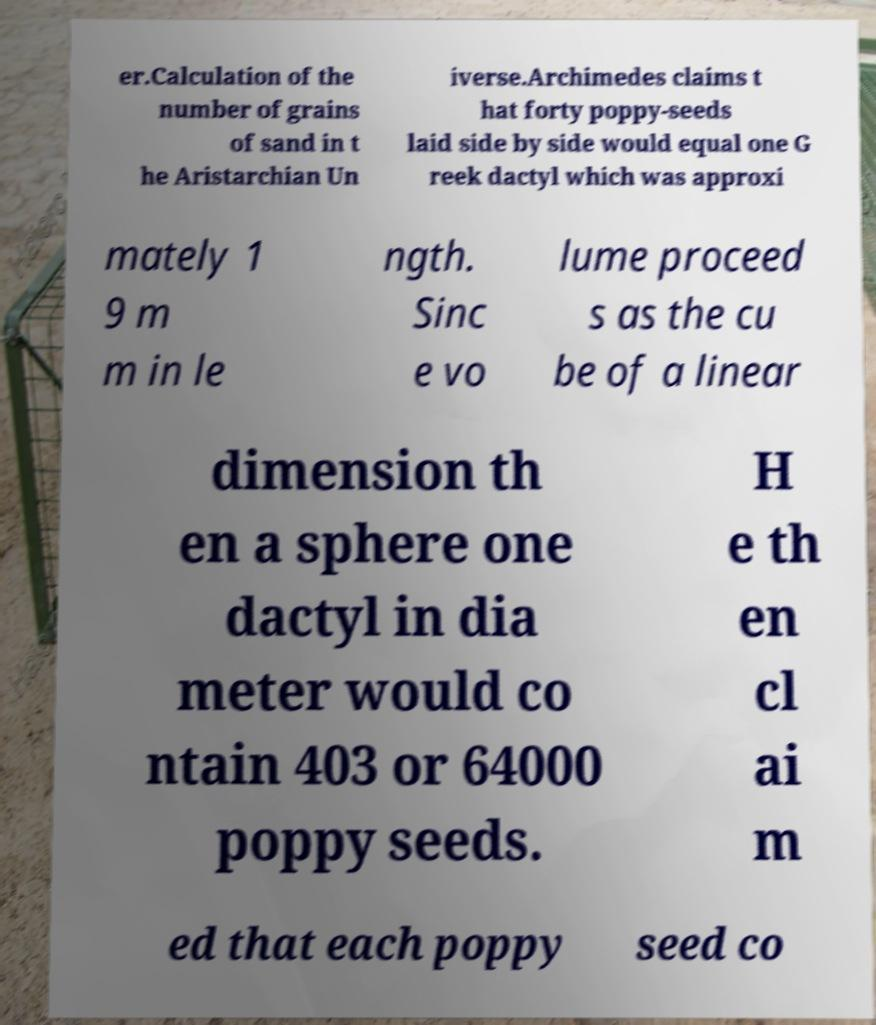Could you assist in decoding the text presented in this image and type it out clearly? er.Calculation of the number of grains of sand in t he Aristarchian Un iverse.Archimedes claims t hat forty poppy-seeds laid side by side would equal one G reek dactyl which was approxi mately 1 9 m m in le ngth. Sinc e vo lume proceed s as the cu be of a linear dimension th en a sphere one dactyl in dia meter would co ntain 403 or 64000 poppy seeds. H e th en cl ai m ed that each poppy seed co 